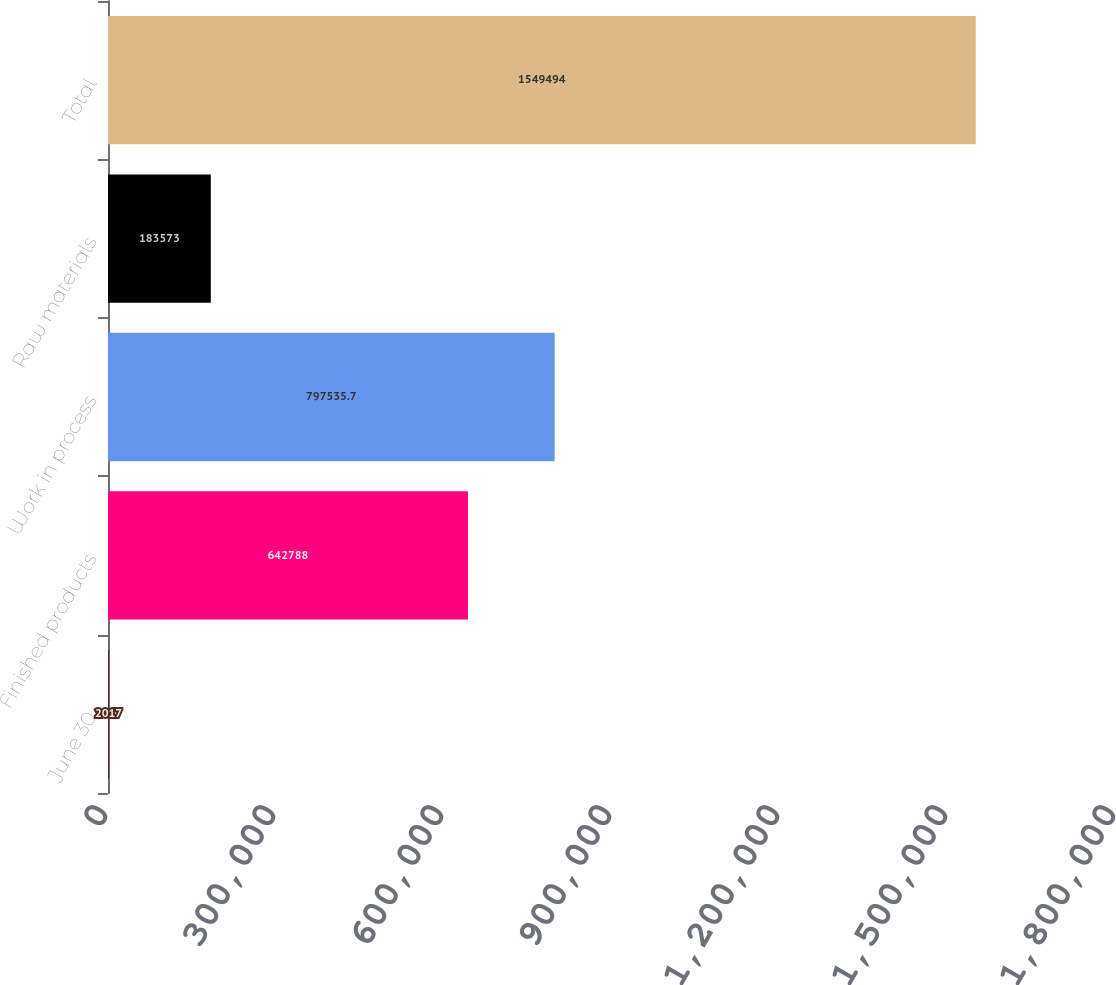<chart> <loc_0><loc_0><loc_500><loc_500><bar_chart><fcel>June 30<fcel>Finished products<fcel>Work in process<fcel>Raw materials<fcel>Total<nl><fcel>2017<fcel>642788<fcel>797536<fcel>183573<fcel>1.54949e+06<nl></chart> 